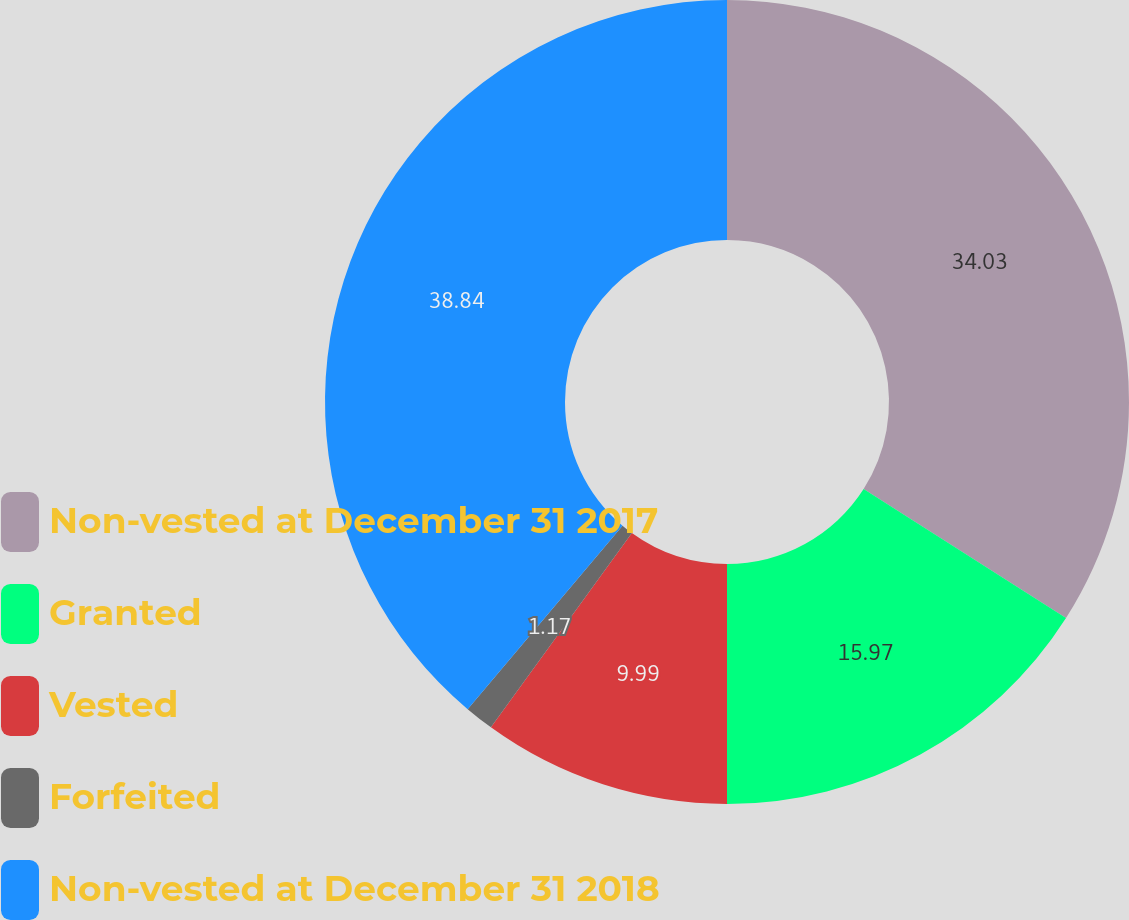<chart> <loc_0><loc_0><loc_500><loc_500><pie_chart><fcel>Non-vested at December 31 2017<fcel>Granted<fcel>Vested<fcel>Forfeited<fcel>Non-vested at December 31 2018<nl><fcel>34.03%<fcel>15.97%<fcel>9.99%<fcel>1.17%<fcel>38.84%<nl></chart> 